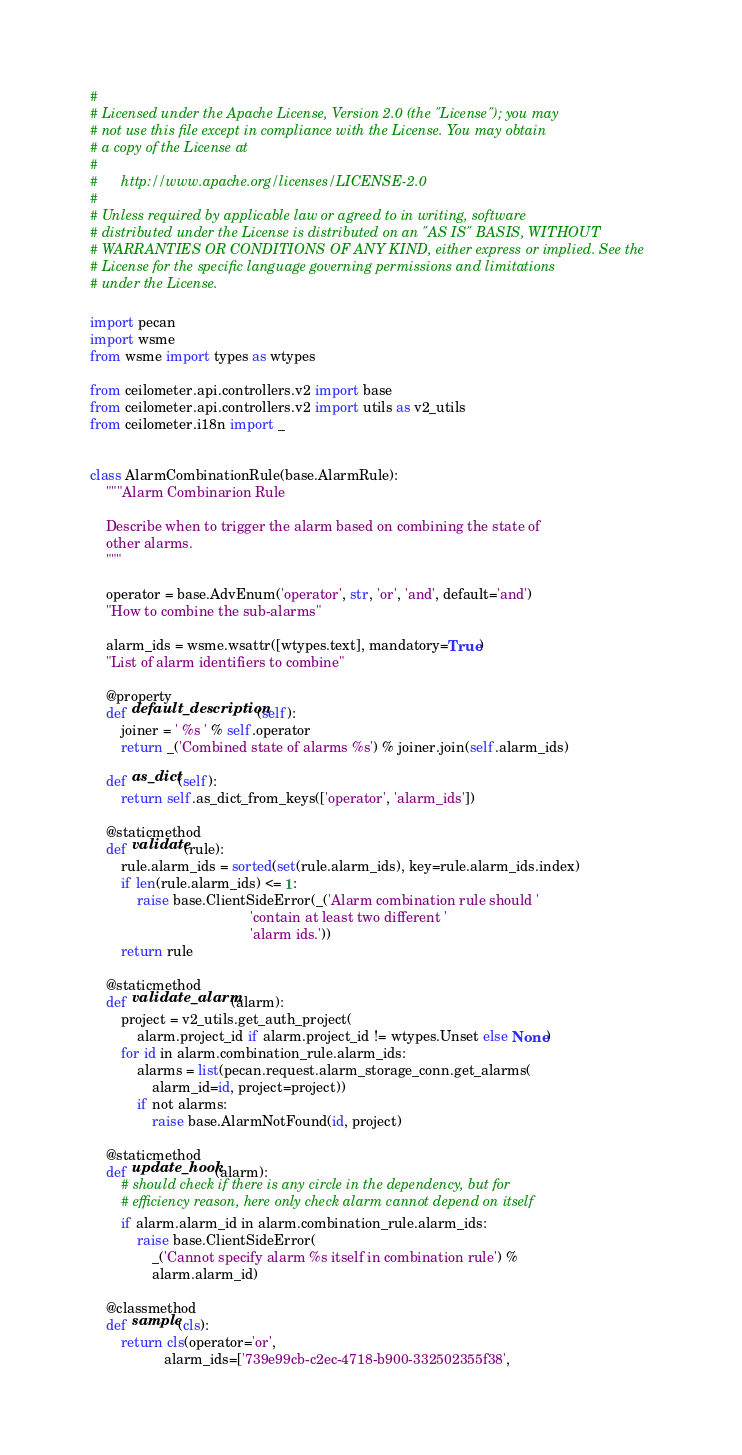<code> <loc_0><loc_0><loc_500><loc_500><_Python_>#
# Licensed under the Apache License, Version 2.0 (the "License"); you may
# not use this file except in compliance with the License. You may obtain
# a copy of the License at
#
#      http://www.apache.org/licenses/LICENSE-2.0
#
# Unless required by applicable law or agreed to in writing, software
# distributed under the License is distributed on an "AS IS" BASIS, WITHOUT
# WARRANTIES OR CONDITIONS OF ANY KIND, either express or implied. See the
# License for the specific language governing permissions and limitations
# under the License.

import pecan
import wsme
from wsme import types as wtypes

from ceilometer.api.controllers.v2 import base
from ceilometer.api.controllers.v2 import utils as v2_utils
from ceilometer.i18n import _


class AlarmCombinationRule(base.AlarmRule):
    """Alarm Combinarion Rule

    Describe when to trigger the alarm based on combining the state of
    other alarms.
    """

    operator = base.AdvEnum('operator', str, 'or', 'and', default='and')
    "How to combine the sub-alarms"

    alarm_ids = wsme.wsattr([wtypes.text], mandatory=True)
    "List of alarm identifiers to combine"

    @property
    def default_description(self):
        joiner = ' %s ' % self.operator
        return _('Combined state of alarms %s') % joiner.join(self.alarm_ids)

    def as_dict(self):
        return self.as_dict_from_keys(['operator', 'alarm_ids'])

    @staticmethod
    def validate(rule):
        rule.alarm_ids = sorted(set(rule.alarm_ids), key=rule.alarm_ids.index)
        if len(rule.alarm_ids) <= 1:
            raise base.ClientSideError(_('Alarm combination rule should '
                                         'contain at least two different '
                                         'alarm ids.'))
        return rule

    @staticmethod
    def validate_alarm(alarm):
        project = v2_utils.get_auth_project(
            alarm.project_id if alarm.project_id != wtypes.Unset else None)
        for id in alarm.combination_rule.alarm_ids:
            alarms = list(pecan.request.alarm_storage_conn.get_alarms(
                alarm_id=id, project=project))
            if not alarms:
                raise base.AlarmNotFound(id, project)

    @staticmethod
    def update_hook(alarm):
        # should check if there is any circle in the dependency, but for
        # efficiency reason, here only check alarm cannot depend on itself
        if alarm.alarm_id in alarm.combination_rule.alarm_ids:
            raise base.ClientSideError(
                _('Cannot specify alarm %s itself in combination rule') %
                alarm.alarm_id)

    @classmethod
    def sample(cls):
        return cls(operator='or',
                   alarm_ids=['739e99cb-c2ec-4718-b900-332502355f38',</code> 